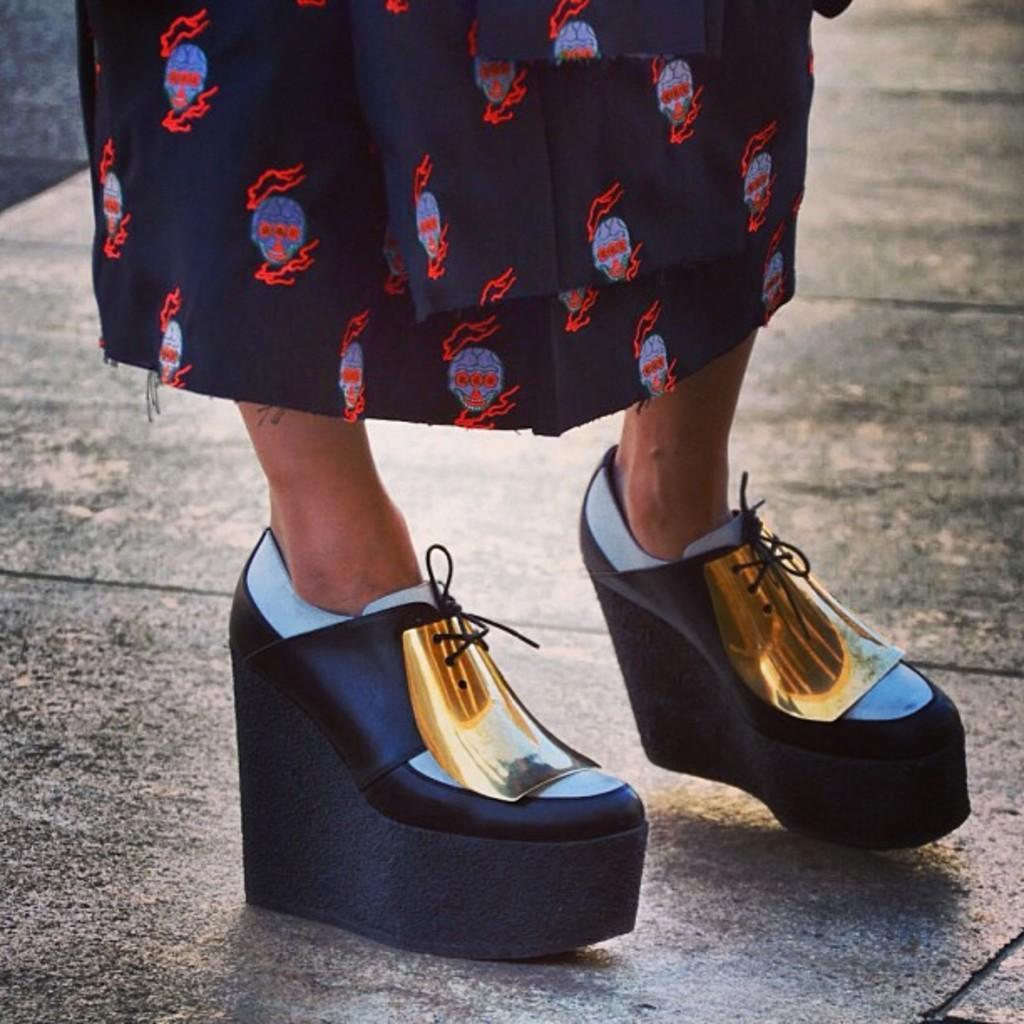Describe this image in one or two sentences. In this image we can see a person standing on the surface wearing the sandals. 